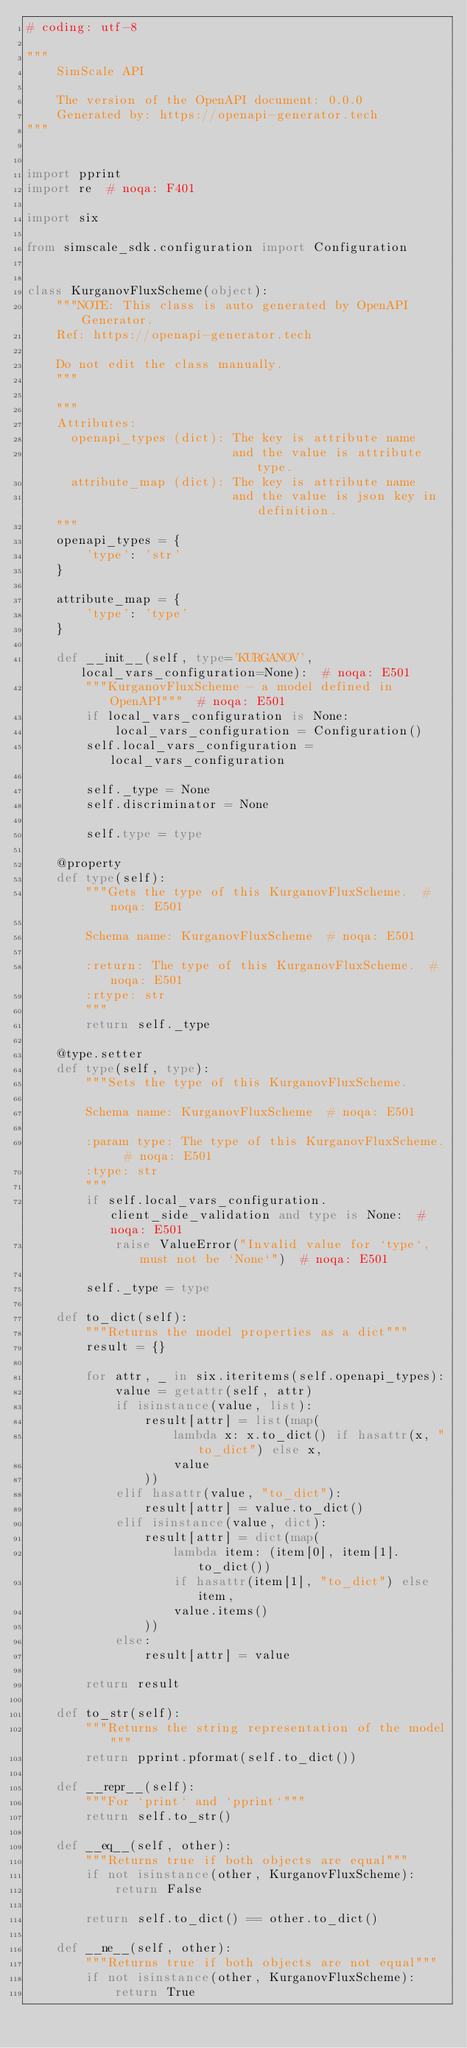<code> <loc_0><loc_0><loc_500><loc_500><_Python_># coding: utf-8

"""
    SimScale API

    The version of the OpenAPI document: 0.0.0
    Generated by: https://openapi-generator.tech
"""


import pprint
import re  # noqa: F401

import six

from simscale_sdk.configuration import Configuration


class KurganovFluxScheme(object):
    """NOTE: This class is auto generated by OpenAPI Generator.
    Ref: https://openapi-generator.tech

    Do not edit the class manually.
    """

    """
    Attributes:
      openapi_types (dict): The key is attribute name
                            and the value is attribute type.
      attribute_map (dict): The key is attribute name
                            and the value is json key in definition.
    """
    openapi_types = {
        'type': 'str'
    }

    attribute_map = {
        'type': 'type'
    }

    def __init__(self, type='KURGANOV', local_vars_configuration=None):  # noqa: E501
        """KurganovFluxScheme - a model defined in OpenAPI"""  # noqa: E501
        if local_vars_configuration is None:
            local_vars_configuration = Configuration()
        self.local_vars_configuration = local_vars_configuration

        self._type = None
        self.discriminator = None

        self.type = type

    @property
    def type(self):
        """Gets the type of this KurganovFluxScheme.  # noqa: E501

        Schema name: KurganovFluxScheme  # noqa: E501

        :return: The type of this KurganovFluxScheme.  # noqa: E501
        :rtype: str
        """
        return self._type

    @type.setter
    def type(self, type):
        """Sets the type of this KurganovFluxScheme.

        Schema name: KurganovFluxScheme  # noqa: E501

        :param type: The type of this KurganovFluxScheme.  # noqa: E501
        :type: str
        """
        if self.local_vars_configuration.client_side_validation and type is None:  # noqa: E501
            raise ValueError("Invalid value for `type`, must not be `None`")  # noqa: E501

        self._type = type

    def to_dict(self):
        """Returns the model properties as a dict"""
        result = {}

        for attr, _ in six.iteritems(self.openapi_types):
            value = getattr(self, attr)
            if isinstance(value, list):
                result[attr] = list(map(
                    lambda x: x.to_dict() if hasattr(x, "to_dict") else x,
                    value
                ))
            elif hasattr(value, "to_dict"):
                result[attr] = value.to_dict()
            elif isinstance(value, dict):
                result[attr] = dict(map(
                    lambda item: (item[0], item[1].to_dict())
                    if hasattr(item[1], "to_dict") else item,
                    value.items()
                ))
            else:
                result[attr] = value

        return result

    def to_str(self):
        """Returns the string representation of the model"""
        return pprint.pformat(self.to_dict())

    def __repr__(self):
        """For `print` and `pprint`"""
        return self.to_str()

    def __eq__(self, other):
        """Returns true if both objects are equal"""
        if not isinstance(other, KurganovFluxScheme):
            return False

        return self.to_dict() == other.to_dict()

    def __ne__(self, other):
        """Returns true if both objects are not equal"""
        if not isinstance(other, KurganovFluxScheme):
            return True
</code> 